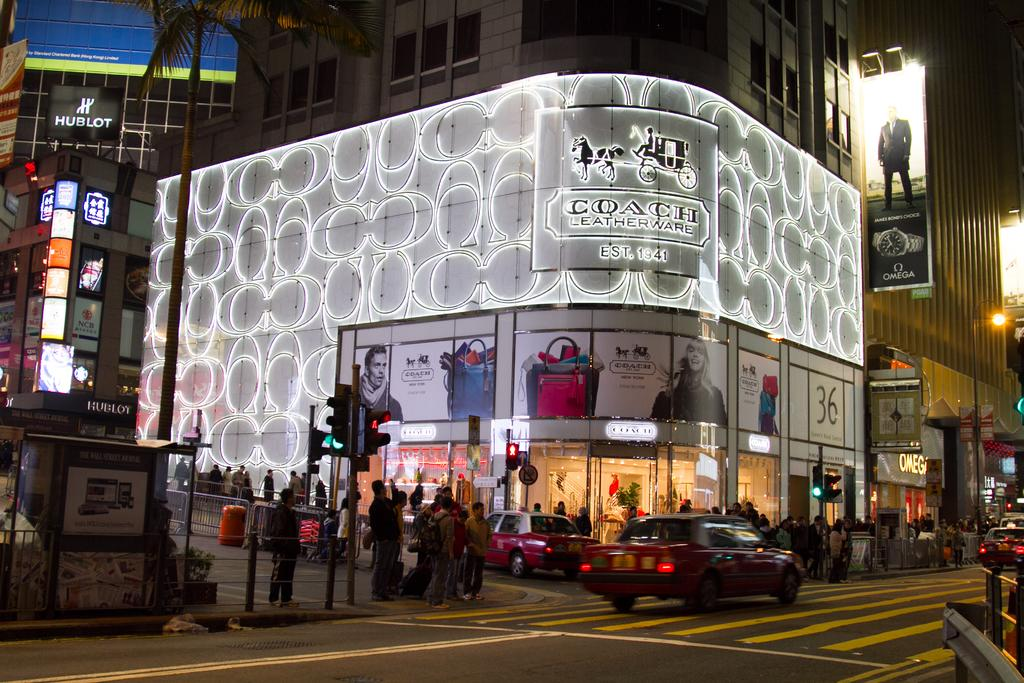<image>
Render a clear and concise summary of the photo. The sidewalk is full of pedestrians in front of the Coach Leatherware building at night. 